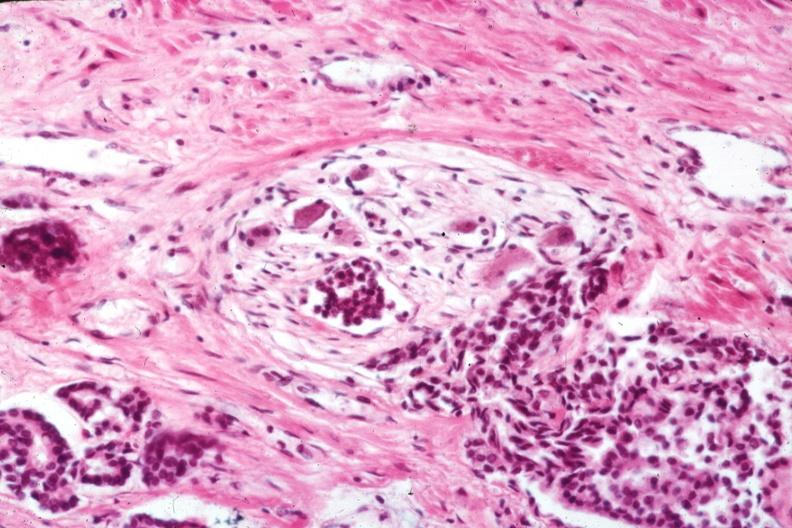s prostate present?
Answer the question using a single word or phrase. Yes 